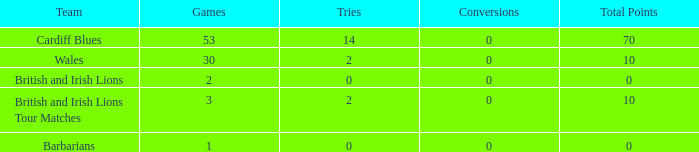Write the full table. {'header': ['Team', 'Games', 'Tries', 'Conversions', 'Total Points'], 'rows': [['Cardiff Blues', '53', '14', '0', '70'], ['Wales', '30', '2', '0', '10'], ['British and Irish Lions', '2', '0', '0', '0'], ['British and Irish Lions Tour Matches', '3', '2', '0', '10'], ['Barbarians', '1', '0', '0', '0']]} What is the average number of tries for British and Irish Lions with less than 2 games? None. 